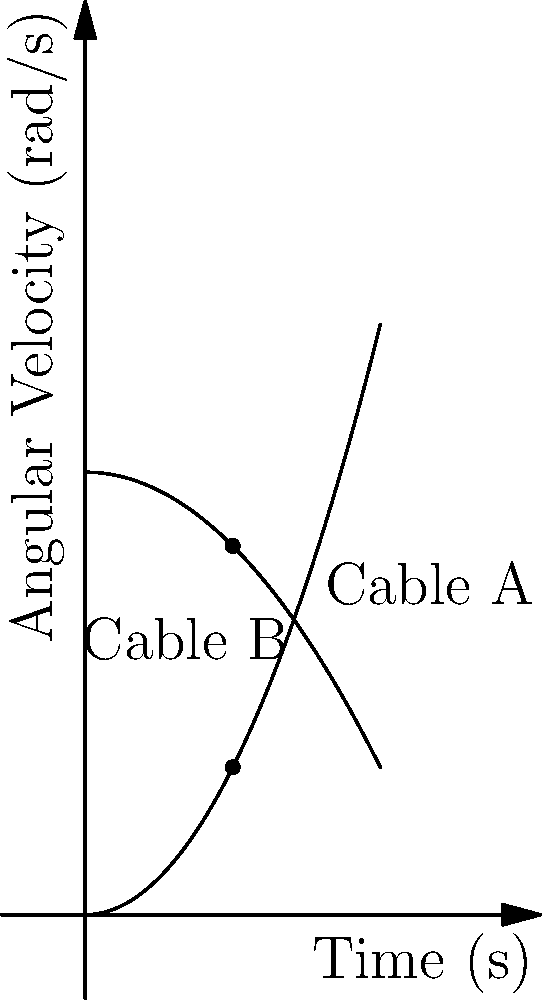The graph shows the angular velocities of two suspension cables (A and B) on the Bosphorus Bridge as functions of time. At $t=10$ seconds, the angular velocity of cable A is $\omega_A = 10$ rad/s. What is the angular velocity of cable B at the same time, and what is the relative angular velocity between the two cables? Let's approach this step-by-step:

1) From the graph, we can see that Cable A's angular velocity is described by the function $\omega_A = 0.1t^2$.

2) Cable B's angular velocity is described by the function $\omega_B = 30 - 0.05t^2$.

3) At $t=10$ seconds:
   For Cable A: $\omega_A = 0.1(10)^2 = 10$ rad/s (as given in the question)
   
   For Cable B: $\omega_B = 30 - 0.05(10)^2 = 30 - 5 = 25$ rad/s

4) To find the relative angular velocity, we subtract:
   $\omega_{relative} = \omega_B - \omega_A = 25 - 10 = 15$ rad/s

Therefore, at $t=10$ seconds, Cable B's angular velocity is 25 rad/s, and the relative angular velocity between the two cables is 15 rad/s.
Answer: $\omega_B = 25$ rad/s, $\omega_{relative} = 15$ rad/s 